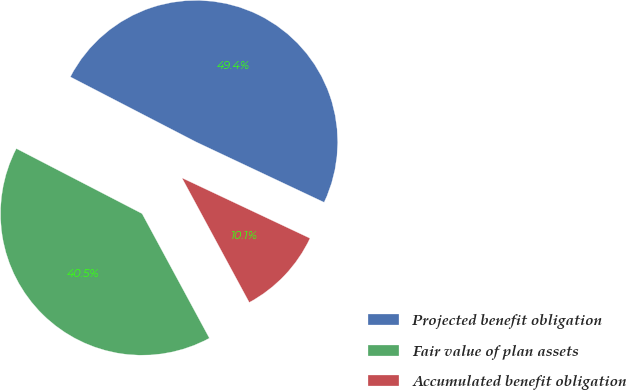Convert chart to OTSL. <chart><loc_0><loc_0><loc_500><loc_500><pie_chart><fcel>Projected benefit obligation<fcel>Fair value of plan assets<fcel>Accumulated benefit obligation<nl><fcel>49.41%<fcel>40.49%<fcel>10.1%<nl></chart> 